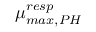Convert formula to latex. <formula><loc_0><loc_0><loc_500><loc_500>\mu _ { \max , P H } ^ { r e s p }</formula> 